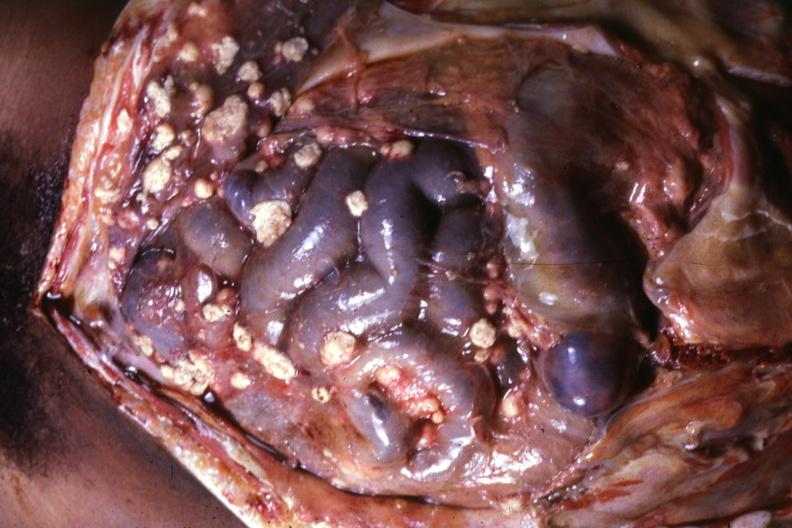s peritoneum present?
Answer the question using a single word or phrase. Yes 